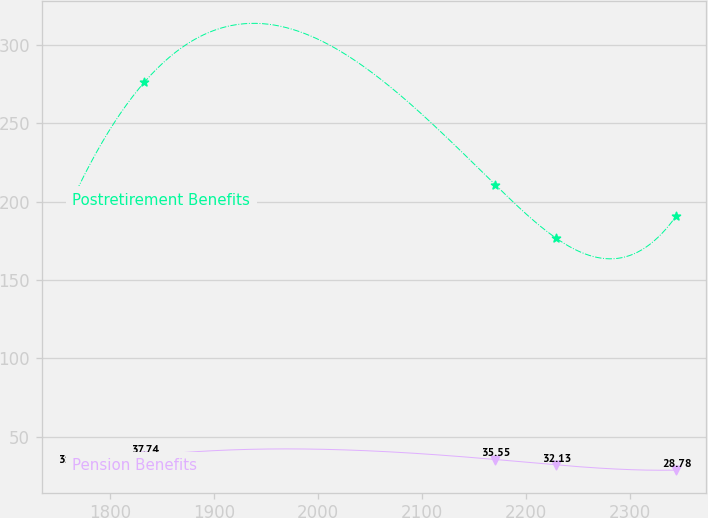<chart> <loc_0><loc_0><loc_500><loc_500><line_chart><ecel><fcel>Postretirement Benefits<fcel>Pension Benefits<nl><fcel>1763.65<fcel>200.81<fcel>31.23<nl><fcel>1833.12<fcel>276.22<fcel>37.74<nl><fcel>2170.44<fcel>210.75<fcel>35.55<nl><fcel>2228.48<fcel>176.85<fcel>32.13<nl><fcel>2344.07<fcel>190.87<fcel>28.78<nl></chart> 